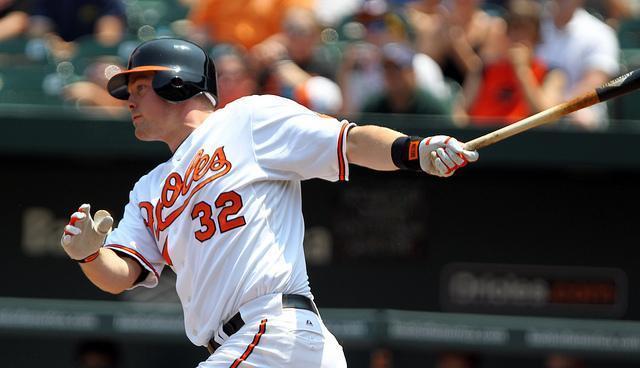How many baseball gloves are visible?
Give a very brief answer. 2. How many people are in the picture?
Give a very brief answer. 2. 